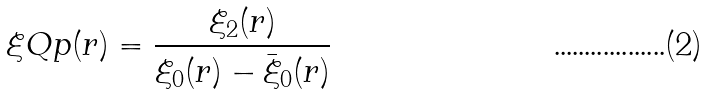Convert formula to latex. <formula><loc_0><loc_0><loc_500><loc_500>\xi Q p ( r ) = \frac { \xi _ { 2 } ( r ) } { \xi _ { 0 } ( r ) - \bar { \xi } _ { 0 } ( r ) }</formula> 